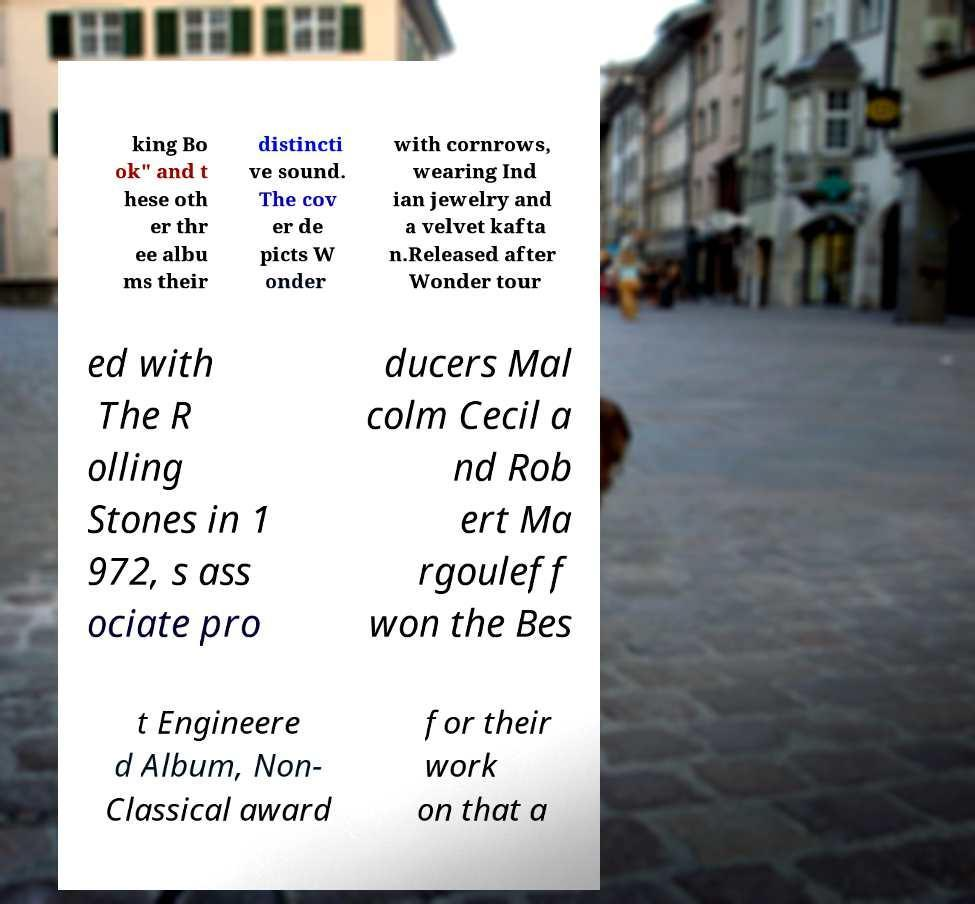Please read and relay the text visible in this image. What does it say? king Bo ok" and t hese oth er thr ee albu ms their distincti ve sound. The cov er de picts W onder with cornrows, wearing Ind ian jewelry and a velvet kafta n.Released after Wonder tour ed with The R olling Stones in 1 972, s ass ociate pro ducers Mal colm Cecil a nd Rob ert Ma rgouleff won the Bes t Engineere d Album, Non- Classical award for their work on that a 